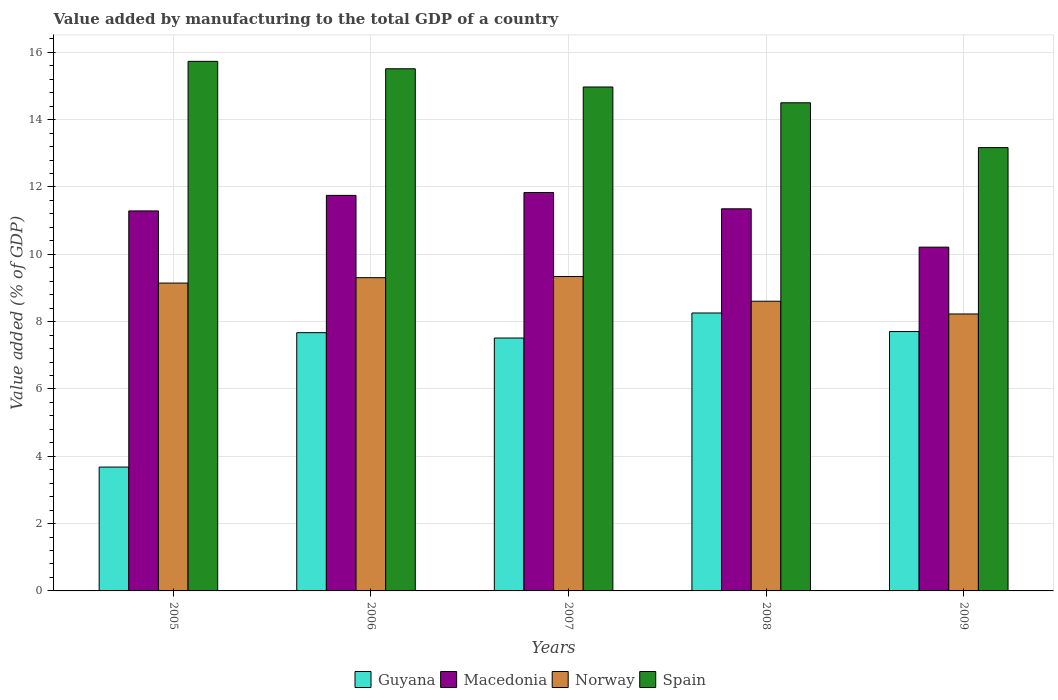How many groups of bars are there?
Give a very brief answer. 5. Are the number of bars on each tick of the X-axis equal?
Your answer should be very brief. Yes. What is the value added by manufacturing to the total GDP in Guyana in 2009?
Your response must be concise. 7.71. Across all years, what is the maximum value added by manufacturing to the total GDP in Guyana?
Provide a succinct answer. 8.26. Across all years, what is the minimum value added by manufacturing to the total GDP in Guyana?
Your answer should be very brief. 3.68. In which year was the value added by manufacturing to the total GDP in Guyana maximum?
Make the answer very short. 2008. In which year was the value added by manufacturing to the total GDP in Guyana minimum?
Give a very brief answer. 2005. What is the total value added by manufacturing to the total GDP in Macedonia in the graph?
Ensure brevity in your answer.  56.44. What is the difference between the value added by manufacturing to the total GDP in Spain in 2008 and that in 2009?
Make the answer very short. 1.33. What is the difference between the value added by manufacturing to the total GDP in Norway in 2007 and the value added by manufacturing to the total GDP in Spain in 2009?
Give a very brief answer. -3.83. What is the average value added by manufacturing to the total GDP in Macedonia per year?
Your response must be concise. 11.29. In the year 2008, what is the difference between the value added by manufacturing to the total GDP in Spain and value added by manufacturing to the total GDP in Norway?
Ensure brevity in your answer.  5.9. In how many years, is the value added by manufacturing to the total GDP in Norway greater than 10.8 %?
Keep it short and to the point. 0. What is the ratio of the value added by manufacturing to the total GDP in Norway in 2005 to that in 2009?
Provide a short and direct response. 1.11. Is the difference between the value added by manufacturing to the total GDP in Spain in 2005 and 2009 greater than the difference between the value added by manufacturing to the total GDP in Norway in 2005 and 2009?
Your response must be concise. Yes. What is the difference between the highest and the second highest value added by manufacturing to the total GDP in Spain?
Provide a short and direct response. 0.22. What is the difference between the highest and the lowest value added by manufacturing to the total GDP in Macedonia?
Provide a succinct answer. 1.62. In how many years, is the value added by manufacturing to the total GDP in Norway greater than the average value added by manufacturing to the total GDP in Norway taken over all years?
Your answer should be compact. 3. Is the sum of the value added by manufacturing to the total GDP in Norway in 2006 and 2007 greater than the maximum value added by manufacturing to the total GDP in Macedonia across all years?
Give a very brief answer. Yes. Is it the case that in every year, the sum of the value added by manufacturing to the total GDP in Norway and value added by manufacturing to the total GDP in Spain is greater than the sum of value added by manufacturing to the total GDP in Macedonia and value added by manufacturing to the total GDP in Guyana?
Give a very brief answer. Yes. What does the 2nd bar from the left in 2008 represents?
Offer a very short reply. Macedonia. What does the 4th bar from the right in 2009 represents?
Provide a succinct answer. Guyana. What is the difference between two consecutive major ticks on the Y-axis?
Provide a succinct answer. 2. Does the graph contain grids?
Your answer should be very brief. Yes. How many legend labels are there?
Provide a succinct answer. 4. How are the legend labels stacked?
Provide a succinct answer. Horizontal. What is the title of the graph?
Ensure brevity in your answer.  Value added by manufacturing to the total GDP of a country. What is the label or title of the Y-axis?
Your response must be concise. Value added (% of GDP). What is the Value added (% of GDP) in Guyana in 2005?
Offer a very short reply. 3.68. What is the Value added (% of GDP) in Macedonia in 2005?
Your answer should be very brief. 11.29. What is the Value added (% of GDP) of Norway in 2005?
Keep it short and to the point. 9.15. What is the Value added (% of GDP) of Spain in 2005?
Make the answer very short. 15.73. What is the Value added (% of GDP) of Guyana in 2006?
Provide a short and direct response. 7.67. What is the Value added (% of GDP) of Macedonia in 2006?
Offer a very short reply. 11.75. What is the Value added (% of GDP) of Norway in 2006?
Your response must be concise. 9.31. What is the Value added (% of GDP) in Spain in 2006?
Offer a terse response. 15.51. What is the Value added (% of GDP) of Guyana in 2007?
Give a very brief answer. 7.51. What is the Value added (% of GDP) of Macedonia in 2007?
Give a very brief answer. 11.84. What is the Value added (% of GDP) in Norway in 2007?
Your answer should be compact. 9.34. What is the Value added (% of GDP) of Spain in 2007?
Your response must be concise. 14.97. What is the Value added (% of GDP) in Guyana in 2008?
Your answer should be compact. 8.26. What is the Value added (% of GDP) of Macedonia in 2008?
Your answer should be compact. 11.35. What is the Value added (% of GDP) in Norway in 2008?
Offer a very short reply. 8.61. What is the Value added (% of GDP) of Spain in 2008?
Offer a terse response. 14.5. What is the Value added (% of GDP) of Guyana in 2009?
Your answer should be compact. 7.71. What is the Value added (% of GDP) in Macedonia in 2009?
Offer a very short reply. 10.21. What is the Value added (% of GDP) in Norway in 2009?
Provide a short and direct response. 8.23. What is the Value added (% of GDP) in Spain in 2009?
Offer a terse response. 13.17. Across all years, what is the maximum Value added (% of GDP) in Guyana?
Your answer should be very brief. 8.26. Across all years, what is the maximum Value added (% of GDP) in Macedonia?
Your answer should be very brief. 11.84. Across all years, what is the maximum Value added (% of GDP) in Norway?
Provide a short and direct response. 9.34. Across all years, what is the maximum Value added (% of GDP) of Spain?
Keep it short and to the point. 15.73. Across all years, what is the minimum Value added (% of GDP) in Guyana?
Provide a succinct answer. 3.68. Across all years, what is the minimum Value added (% of GDP) in Macedonia?
Your response must be concise. 10.21. Across all years, what is the minimum Value added (% of GDP) of Norway?
Offer a very short reply. 8.23. Across all years, what is the minimum Value added (% of GDP) of Spain?
Offer a very short reply. 13.17. What is the total Value added (% of GDP) of Guyana in the graph?
Ensure brevity in your answer.  34.83. What is the total Value added (% of GDP) of Macedonia in the graph?
Your answer should be very brief. 56.44. What is the total Value added (% of GDP) in Norway in the graph?
Provide a short and direct response. 44.63. What is the total Value added (% of GDP) of Spain in the graph?
Your answer should be compact. 73.89. What is the difference between the Value added (% of GDP) in Guyana in 2005 and that in 2006?
Keep it short and to the point. -3.99. What is the difference between the Value added (% of GDP) in Macedonia in 2005 and that in 2006?
Provide a succinct answer. -0.46. What is the difference between the Value added (% of GDP) in Norway in 2005 and that in 2006?
Give a very brief answer. -0.16. What is the difference between the Value added (% of GDP) of Spain in 2005 and that in 2006?
Keep it short and to the point. 0.22. What is the difference between the Value added (% of GDP) of Guyana in 2005 and that in 2007?
Offer a terse response. -3.83. What is the difference between the Value added (% of GDP) in Macedonia in 2005 and that in 2007?
Ensure brevity in your answer.  -0.55. What is the difference between the Value added (% of GDP) in Norway in 2005 and that in 2007?
Make the answer very short. -0.19. What is the difference between the Value added (% of GDP) of Spain in 2005 and that in 2007?
Your answer should be compact. 0.76. What is the difference between the Value added (% of GDP) in Guyana in 2005 and that in 2008?
Offer a very short reply. -4.58. What is the difference between the Value added (% of GDP) of Macedonia in 2005 and that in 2008?
Offer a terse response. -0.06. What is the difference between the Value added (% of GDP) in Norway in 2005 and that in 2008?
Give a very brief answer. 0.54. What is the difference between the Value added (% of GDP) of Spain in 2005 and that in 2008?
Make the answer very short. 1.23. What is the difference between the Value added (% of GDP) of Guyana in 2005 and that in 2009?
Your answer should be very brief. -4.03. What is the difference between the Value added (% of GDP) in Macedonia in 2005 and that in 2009?
Make the answer very short. 1.08. What is the difference between the Value added (% of GDP) in Norway in 2005 and that in 2009?
Give a very brief answer. 0.92. What is the difference between the Value added (% of GDP) of Spain in 2005 and that in 2009?
Give a very brief answer. 2.56. What is the difference between the Value added (% of GDP) in Guyana in 2006 and that in 2007?
Make the answer very short. 0.16. What is the difference between the Value added (% of GDP) of Macedonia in 2006 and that in 2007?
Offer a terse response. -0.08. What is the difference between the Value added (% of GDP) of Norway in 2006 and that in 2007?
Provide a short and direct response. -0.03. What is the difference between the Value added (% of GDP) of Spain in 2006 and that in 2007?
Ensure brevity in your answer.  0.54. What is the difference between the Value added (% of GDP) of Guyana in 2006 and that in 2008?
Offer a very short reply. -0.58. What is the difference between the Value added (% of GDP) in Macedonia in 2006 and that in 2008?
Provide a succinct answer. 0.4. What is the difference between the Value added (% of GDP) in Norway in 2006 and that in 2008?
Offer a terse response. 0.7. What is the difference between the Value added (% of GDP) of Spain in 2006 and that in 2008?
Your response must be concise. 1.01. What is the difference between the Value added (% of GDP) of Guyana in 2006 and that in 2009?
Keep it short and to the point. -0.03. What is the difference between the Value added (% of GDP) of Macedonia in 2006 and that in 2009?
Your answer should be compact. 1.54. What is the difference between the Value added (% of GDP) of Norway in 2006 and that in 2009?
Offer a very short reply. 1.08. What is the difference between the Value added (% of GDP) in Spain in 2006 and that in 2009?
Make the answer very short. 2.34. What is the difference between the Value added (% of GDP) of Guyana in 2007 and that in 2008?
Your answer should be very brief. -0.74. What is the difference between the Value added (% of GDP) of Macedonia in 2007 and that in 2008?
Keep it short and to the point. 0.48. What is the difference between the Value added (% of GDP) in Norway in 2007 and that in 2008?
Your answer should be compact. 0.73. What is the difference between the Value added (% of GDP) in Spain in 2007 and that in 2008?
Provide a short and direct response. 0.47. What is the difference between the Value added (% of GDP) in Guyana in 2007 and that in 2009?
Your answer should be compact. -0.19. What is the difference between the Value added (% of GDP) of Macedonia in 2007 and that in 2009?
Keep it short and to the point. 1.62. What is the difference between the Value added (% of GDP) in Norway in 2007 and that in 2009?
Your answer should be compact. 1.11. What is the difference between the Value added (% of GDP) of Spain in 2007 and that in 2009?
Give a very brief answer. 1.8. What is the difference between the Value added (% of GDP) in Guyana in 2008 and that in 2009?
Give a very brief answer. 0.55. What is the difference between the Value added (% of GDP) in Macedonia in 2008 and that in 2009?
Make the answer very short. 1.14. What is the difference between the Value added (% of GDP) of Norway in 2008 and that in 2009?
Your response must be concise. 0.38. What is the difference between the Value added (% of GDP) of Spain in 2008 and that in 2009?
Provide a succinct answer. 1.33. What is the difference between the Value added (% of GDP) in Guyana in 2005 and the Value added (% of GDP) in Macedonia in 2006?
Make the answer very short. -8.07. What is the difference between the Value added (% of GDP) in Guyana in 2005 and the Value added (% of GDP) in Norway in 2006?
Your response must be concise. -5.63. What is the difference between the Value added (% of GDP) of Guyana in 2005 and the Value added (% of GDP) of Spain in 2006?
Your answer should be very brief. -11.83. What is the difference between the Value added (% of GDP) in Macedonia in 2005 and the Value added (% of GDP) in Norway in 2006?
Ensure brevity in your answer.  1.98. What is the difference between the Value added (% of GDP) of Macedonia in 2005 and the Value added (% of GDP) of Spain in 2006?
Your answer should be very brief. -4.22. What is the difference between the Value added (% of GDP) of Norway in 2005 and the Value added (% of GDP) of Spain in 2006?
Ensure brevity in your answer.  -6.37. What is the difference between the Value added (% of GDP) of Guyana in 2005 and the Value added (% of GDP) of Macedonia in 2007?
Your answer should be compact. -8.16. What is the difference between the Value added (% of GDP) of Guyana in 2005 and the Value added (% of GDP) of Norway in 2007?
Offer a terse response. -5.66. What is the difference between the Value added (% of GDP) in Guyana in 2005 and the Value added (% of GDP) in Spain in 2007?
Provide a short and direct response. -11.29. What is the difference between the Value added (% of GDP) of Macedonia in 2005 and the Value added (% of GDP) of Norway in 2007?
Make the answer very short. 1.95. What is the difference between the Value added (% of GDP) of Macedonia in 2005 and the Value added (% of GDP) of Spain in 2007?
Provide a short and direct response. -3.68. What is the difference between the Value added (% of GDP) of Norway in 2005 and the Value added (% of GDP) of Spain in 2007?
Make the answer very short. -5.83. What is the difference between the Value added (% of GDP) in Guyana in 2005 and the Value added (% of GDP) in Macedonia in 2008?
Your answer should be compact. -7.67. What is the difference between the Value added (% of GDP) in Guyana in 2005 and the Value added (% of GDP) in Norway in 2008?
Your response must be concise. -4.93. What is the difference between the Value added (% of GDP) of Guyana in 2005 and the Value added (% of GDP) of Spain in 2008?
Offer a terse response. -10.82. What is the difference between the Value added (% of GDP) in Macedonia in 2005 and the Value added (% of GDP) in Norway in 2008?
Offer a terse response. 2.68. What is the difference between the Value added (% of GDP) in Macedonia in 2005 and the Value added (% of GDP) in Spain in 2008?
Your answer should be very brief. -3.21. What is the difference between the Value added (% of GDP) of Norway in 2005 and the Value added (% of GDP) of Spain in 2008?
Give a very brief answer. -5.36. What is the difference between the Value added (% of GDP) of Guyana in 2005 and the Value added (% of GDP) of Macedonia in 2009?
Ensure brevity in your answer.  -6.53. What is the difference between the Value added (% of GDP) in Guyana in 2005 and the Value added (% of GDP) in Norway in 2009?
Make the answer very short. -4.55. What is the difference between the Value added (% of GDP) in Guyana in 2005 and the Value added (% of GDP) in Spain in 2009?
Provide a succinct answer. -9.49. What is the difference between the Value added (% of GDP) in Macedonia in 2005 and the Value added (% of GDP) in Norway in 2009?
Provide a short and direct response. 3.06. What is the difference between the Value added (% of GDP) in Macedonia in 2005 and the Value added (% of GDP) in Spain in 2009?
Your answer should be compact. -1.88. What is the difference between the Value added (% of GDP) in Norway in 2005 and the Value added (% of GDP) in Spain in 2009?
Your answer should be compact. -4.02. What is the difference between the Value added (% of GDP) in Guyana in 2006 and the Value added (% of GDP) in Macedonia in 2007?
Provide a succinct answer. -4.16. What is the difference between the Value added (% of GDP) of Guyana in 2006 and the Value added (% of GDP) of Norway in 2007?
Your answer should be very brief. -1.67. What is the difference between the Value added (% of GDP) of Guyana in 2006 and the Value added (% of GDP) of Spain in 2007?
Your answer should be compact. -7.3. What is the difference between the Value added (% of GDP) in Macedonia in 2006 and the Value added (% of GDP) in Norway in 2007?
Make the answer very short. 2.41. What is the difference between the Value added (% of GDP) of Macedonia in 2006 and the Value added (% of GDP) of Spain in 2007?
Offer a terse response. -3.22. What is the difference between the Value added (% of GDP) of Norway in 2006 and the Value added (% of GDP) of Spain in 2007?
Ensure brevity in your answer.  -5.66. What is the difference between the Value added (% of GDP) of Guyana in 2006 and the Value added (% of GDP) of Macedonia in 2008?
Your response must be concise. -3.68. What is the difference between the Value added (% of GDP) in Guyana in 2006 and the Value added (% of GDP) in Norway in 2008?
Provide a short and direct response. -0.93. What is the difference between the Value added (% of GDP) of Guyana in 2006 and the Value added (% of GDP) of Spain in 2008?
Make the answer very short. -6.83. What is the difference between the Value added (% of GDP) in Macedonia in 2006 and the Value added (% of GDP) in Norway in 2008?
Offer a terse response. 3.14. What is the difference between the Value added (% of GDP) in Macedonia in 2006 and the Value added (% of GDP) in Spain in 2008?
Keep it short and to the point. -2.75. What is the difference between the Value added (% of GDP) in Norway in 2006 and the Value added (% of GDP) in Spain in 2008?
Your answer should be compact. -5.2. What is the difference between the Value added (% of GDP) in Guyana in 2006 and the Value added (% of GDP) in Macedonia in 2009?
Offer a very short reply. -2.54. What is the difference between the Value added (% of GDP) of Guyana in 2006 and the Value added (% of GDP) of Norway in 2009?
Offer a terse response. -0.56. What is the difference between the Value added (% of GDP) of Guyana in 2006 and the Value added (% of GDP) of Spain in 2009?
Your answer should be compact. -5.5. What is the difference between the Value added (% of GDP) in Macedonia in 2006 and the Value added (% of GDP) in Norway in 2009?
Your answer should be compact. 3.52. What is the difference between the Value added (% of GDP) of Macedonia in 2006 and the Value added (% of GDP) of Spain in 2009?
Provide a short and direct response. -1.42. What is the difference between the Value added (% of GDP) of Norway in 2006 and the Value added (% of GDP) of Spain in 2009?
Offer a very short reply. -3.86. What is the difference between the Value added (% of GDP) in Guyana in 2007 and the Value added (% of GDP) in Macedonia in 2008?
Provide a succinct answer. -3.84. What is the difference between the Value added (% of GDP) in Guyana in 2007 and the Value added (% of GDP) in Norway in 2008?
Give a very brief answer. -1.09. What is the difference between the Value added (% of GDP) in Guyana in 2007 and the Value added (% of GDP) in Spain in 2008?
Provide a succinct answer. -6.99. What is the difference between the Value added (% of GDP) of Macedonia in 2007 and the Value added (% of GDP) of Norway in 2008?
Your response must be concise. 3.23. What is the difference between the Value added (% of GDP) of Macedonia in 2007 and the Value added (% of GDP) of Spain in 2008?
Your answer should be compact. -2.67. What is the difference between the Value added (% of GDP) in Norway in 2007 and the Value added (% of GDP) in Spain in 2008?
Provide a succinct answer. -5.16. What is the difference between the Value added (% of GDP) in Guyana in 2007 and the Value added (% of GDP) in Macedonia in 2009?
Ensure brevity in your answer.  -2.7. What is the difference between the Value added (% of GDP) in Guyana in 2007 and the Value added (% of GDP) in Norway in 2009?
Your answer should be compact. -0.71. What is the difference between the Value added (% of GDP) of Guyana in 2007 and the Value added (% of GDP) of Spain in 2009?
Make the answer very short. -5.66. What is the difference between the Value added (% of GDP) in Macedonia in 2007 and the Value added (% of GDP) in Norway in 2009?
Ensure brevity in your answer.  3.61. What is the difference between the Value added (% of GDP) of Macedonia in 2007 and the Value added (% of GDP) of Spain in 2009?
Give a very brief answer. -1.33. What is the difference between the Value added (% of GDP) of Norway in 2007 and the Value added (% of GDP) of Spain in 2009?
Provide a short and direct response. -3.83. What is the difference between the Value added (% of GDP) in Guyana in 2008 and the Value added (% of GDP) in Macedonia in 2009?
Your response must be concise. -1.96. What is the difference between the Value added (% of GDP) of Guyana in 2008 and the Value added (% of GDP) of Norway in 2009?
Offer a very short reply. 0.03. What is the difference between the Value added (% of GDP) in Guyana in 2008 and the Value added (% of GDP) in Spain in 2009?
Your answer should be very brief. -4.91. What is the difference between the Value added (% of GDP) of Macedonia in 2008 and the Value added (% of GDP) of Norway in 2009?
Provide a short and direct response. 3.12. What is the difference between the Value added (% of GDP) in Macedonia in 2008 and the Value added (% of GDP) in Spain in 2009?
Give a very brief answer. -1.82. What is the difference between the Value added (% of GDP) in Norway in 2008 and the Value added (% of GDP) in Spain in 2009?
Provide a succinct answer. -4.56. What is the average Value added (% of GDP) in Guyana per year?
Provide a succinct answer. 6.97. What is the average Value added (% of GDP) in Macedonia per year?
Offer a very short reply. 11.29. What is the average Value added (% of GDP) of Norway per year?
Keep it short and to the point. 8.93. What is the average Value added (% of GDP) in Spain per year?
Your answer should be very brief. 14.78. In the year 2005, what is the difference between the Value added (% of GDP) of Guyana and Value added (% of GDP) of Macedonia?
Make the answer very short. -7.61. In the year 2005, what is the difference between the Value added (% of GDP) of Guyana and Value added (% of GDP) of Norway?
Your answer should be compact. -5.47. In the year 2005, what is the difference between the Value added (% of GDP) in Guyana and Value added (% of GDP) in Spain?
Give a very brief answer. -12.05. In the year 2005, what is the difference between the Value added (% of GDP) in Macedonia and Value added (% of GDP) in Norway?
Offer a very short reply. 2.14. In the year 2005, what is the difference between the Value added (% of GDP) in Macedonia and Value added (% of GDP) in Spain?
Ensure brevity in your answer.  -4.44. In the year 2005, what is the difference between the Value added (% of GDP) of Norway and Value added (% of GDP) of Spain?
Keep it short and to the point. -6.59. In the year 2006, what is the difference between the Value added (% of GDP) of Guyana and Value added (% of GDP) of Macedonia?
Ensure brevity in your answer.  -4.08. In the year 2006, what is the difference between the Value added (% of GDP) in Guyana and Value added (% of GDP) in Norway?
Provide a succinct answer. -1.63. In the year 2006, what is the difference between the Value added (% of GDP) of Guyana and Value added (% of GDP) of Spain?
Keep it short and to the point. -7.84. In the year 2006, what is the difference between the Value added (% of GDP) in Macedonia and Value added (% of GDP) in Norway?
Your answer should be compact. 2.44. In the year 2006, what is the difference between the Value added (% of GDP) in Macedonia and Value added (% of GDP) in Spain?
Offer a very short reply. -3.76. In the year 2006, what is the difference between the Value added (% of GDP) of Norway and Value added (% of GDP) of Spain?
Keep it short and to the point. -6.21. In the year 2007, what is the difference between the Value added (% of GDP) in Guyana and Value added (% of GDP) in Macedonia?
Keep it short and to the point. -4.32. In the year 2007, what is the difference between the Value added (% of GDP) in Guyana and Value added (% of GDP) in Norway?
Make the answer very short. -1.83. In the year 2007, what is the difference between the Value added (% of GDP) in Guyana and Value added (% of GDP) in Spain?
Give a very brief answer. -7.46. In the year 2007, what is the difference between the Value added (% of GDP) of Macedonia and Value added (% of GDP) of Norway?
Provide a short and direct response. 2.5. In the year 2007, what is the difference between the Value added (% of GDP) in Macedonia and Value added (% of GDP) in Spain?
Your response must be concise. -3.14. In the year 2007, what is the difference between the Value added (% of GDP) of Norway and Value added (% of GDP) of Spain?
Ensure brevity in your answer.  -5.63. In the year 2008, what is the difference between the Value added (% of GDP) of Guyana and Value added (% of GDP) of Macedonia?
Ensure brevity in your answer.  -3.09. In the year 2008, what is the difference between the Value added (% of GDP) in Guyana and Value added (% of GDP) in Norway?
Ensure brevity in your answer.  -0.35. In the year 2008, what is the difference between the Value added (% of GDP) of Guyana and Value added (% of GDP) of Spain?
Your answer should be compact. -6.24. In the year 2008, what is the difference between the Value added (% of GDP) in Macedonia and Value added (% of GDP) in Norway?
Keep it short and to the point. 2.75. In the year 2008, what is the difference between the Value added (% of GDP) in Macedonia and Value added (% of GDP) in Spain?
Your answer should be compact. -3.15. In the year 2008, what is the difference between the Value added (% of GDP) in Norway and Value added (% of GDP) in Spain?
Give a very brief answer. -5.9. In the year 2009, what is the difference between the Value added (% of GDP) in Guyana and Value added (% of GDP) in Macedonia?
Your answer should be very brief. -2.51. In the year 2009, what is the difference between the Value added (% of GDP) in Guyana and Value added (% of GDP) in Norway?
Your response must be concise. -0.52. In the year 2009, what is the difference between the Value added (% of GDP) in Guyana and Value added (% of GDP) in Spain?
Your answer should be compact. -5.46. In the year 2009, what is the difference between the Value added (% of GDP) of Macedonia and Value added (% of GDP) of Norway?
Provide a succinct answer. 1.98. In the year 2009, what is the difference between the Value added (% of GDP) of Macedonia and Value added (% of GDP) of Spain?
Offer a terse response. -2.96. In the year 2009, what is the difference between the Value added (% of GDP) in Norway and Value added (% of GDP) in Spain?
Offer a terse response. -4.94. What is the ratio of the Value added (% of GDP) of Guyana in 2005 to that in 2006?
Your answer should be very brief. 0.48. What is the ratio of the Value added (% of GDP) in Macedonia in 2005 to that in 2006?
Offer a very short reply. 0.96. What is the ratio of the Value added (% of GDP) in Norway in 2005 to that in 2006?
Offer a very short reply. 0.98. What is the ratio of the Value added (% of GDP) in Spain in 2005 to that in 2006?
Provide a short and direct response. 1.01. What is the ratio of the Value added (% of GDP) in Guyana in 2005 to that in 2007?
Provide a succinct answer. 0.49. What is the ratio of the Value added (% of GDP) in Macedonia in 2005 to that in 2007?
Your response must be concise. 0.95. What is the ratio of the Value added (% of GDP) in Norway in 2005 to that in 2007?
Keep it short and to the point. 0.98. What is the ratio of the Value added (% of GDP) in Spain in 2005 to that in 2007?
Keep it short and to the point. 1.05. What is the ratio of the Value added (% of GDP) of Guyana in 2005 to that in 2008?
Give a very brief answer. 0.45. What is the ratio of the Value added (% of GDP) of Macedonia in 2005 to that in 2008?
Your answer should be very brief. 0.99. What is the ratio of the Value added (% of GDP) in Norway in 2005 to that in 2008?
Provide a succinct answer. 1.06. What is the ratio of the Value added (% of GDP) in Spain in 2005 to that in 2008?
Your answer should be very brief. 1.08. What is the ratio of the Value added (% of GDP) in Guyana in 2005 to that in 2009?
Give a very brief answer. 0.48. What is the ratio of the Value added (% of GDP) of Macedonia in 2005 to that in 2009?
Make the answer very short. 1.11. What is the ratio of the Value added (% of GDP) in Norway in 2005 to that in 2009?
Provide a succinct answer. 1.11. What is the ratio of the Value added (% of GDP) in Spain in 2005 to that in 2009?
Offer a terse response. 1.19. What is the ratio of the Value added (% of GDP) in Guyana in 2006 to that in 2007?
Make the answer very short. 1.02. What is the ratio of the Value added (% of GDP) in Norway in 2006 to that in 2007?
Keep it short and to the point. 1. What is the ratio of the Value added (% of GDP) of Spain in 2006 to that in 2007?
Provide a succinct answer. 1.04. What is the ratio of the Value added (% of GDP) of Guyana in 2006 to that in 2008?
Your answer should be very brief. 0.93. What is the ratio of the Value added (% of GDP) of Macedonia in 2006 to that in 2008?
Offer a terse response. 1.04. What is the ratio of the Value added (% of GDP) in Norway in 2006 to that in 2008?
Make the answer very short. 1.08. What is the ratio of the Value added (% of GDP) of Spain in 2006 to that in 2008?
Your answer should be compact. 1.07. What is the ratio of the Value added (% of GDP) in Macedonia in 2006 to that in 2009?
Provide a succinct answer. 1.15. What is the ratio of the Value added (% of GDP) of Norway in 2006 to that in 2009?
Ensure brevity in your answer.  1.13. What is the ratio of the Value added (% of GDP) in Spain in 2006 to that in 2009?
Offer a very short reply. 1.18. What is the ratio of the Value added (% of GDP) in Guyana in 2007 to that in 2008?
Give a very brief answer. 0.91. What is the ratio of the Value added (% of GDP) of Macedonia in 2007 to that in 2008?
Provide a succinct answer. 1.04. What is the ratio of the Value added (% of GDP) in Norway in 2007 to that in 2008?
Offer a terse response. 1.09. What is the ratio of the Value added (% of GDP) of Spain in 2007 to that in 2008?
Provide a short and direct response. 1.03. What is the ratio of the Value added (% of GDP) of Guyana in 2007 to that in 2009?
Your answer should be very brief. 0.97. What is the ratio of the Value added (% of GDP) in Macedonia in 2007 to that in 2009?
Keep it short and to the point. 1.16. What is the ratio of the Value added (% of GDP) in Norway in 2007 to that in 2009?
Your answer should be very brief. 1.14. What is the ratio of the Value added (% of GDP) in Spain in 2007 to that in 2009?
Your response must be concise. 1.14. What is the ratio of the Value added (% of GDP) of Guyana in 2008 to that in 2009?
Provide a succinct answer. 1.07. What is the ratio of the Value added (% of GDP) in Macedonia in 2008 to that in 2009?
Keep it short and to the point. 1.11. What is the ratio of the Value added (% of GDP) of Norway in 2008 to that in 2009?
Your answer should be very brief. 1.05. What is the ratio of the Value added (% of GDP) in Spain in 2008 to that in 2009?
Provide a short and direct response. 1.1. What is the difference between the highest and the second highest Value added (% of GDP) of Guyana?
Offer a terse response. 0.55. What is the difference between the highest and the second highest Value added (% of GDP) in Macedonia?
Ensure brevity in your answer.  0.08. What is the difference between the highest and the second highest Value added (% of GDP) in Norway?
Your answer should be compact. 0.03. What is the difference between the highest and the second highest Value added (% of GDP) of Spain?
Make the answer very short. 0.22. What is the difference between the highest and the lowest Value added (% of GDP) in Guyana?
Offer a terse response. 4.58. What is the difference between the highest and the lowest Value added (% of GDP) in Macedonia?
Provide a succinct answer. 1.62. What is the difference between the highest and the lowest Value added (% of GDP) in Norway?
Ensure brevity in your answer.  1.11. What is the difference between the highest and the lowest Value added (% of GDP) of Spain?
Ensure brevity in your answer.  2.56. 